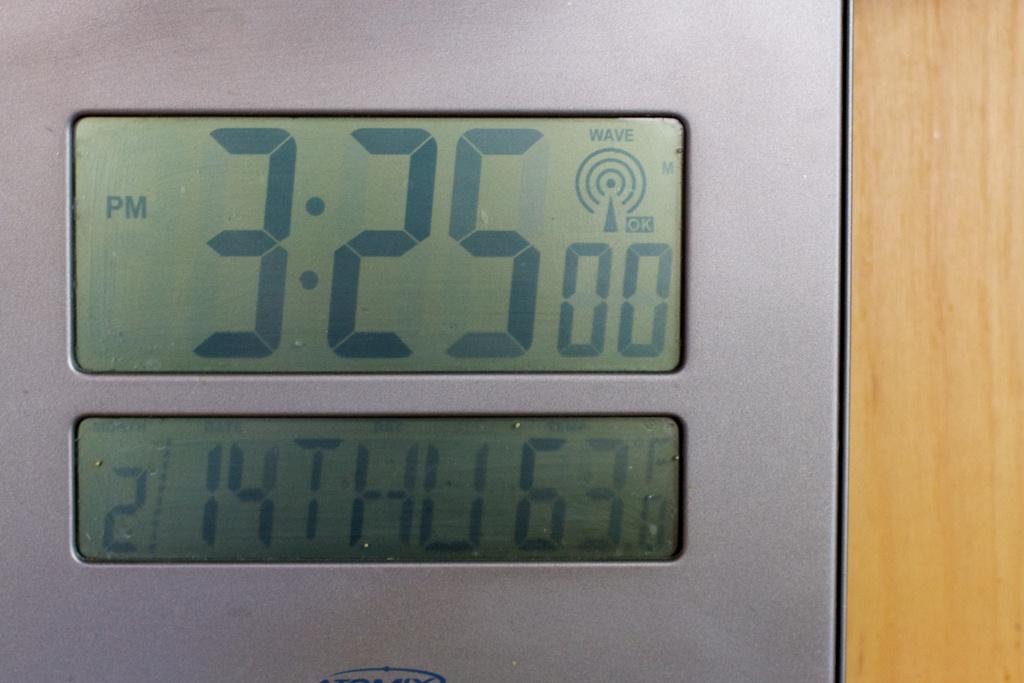What date is on the clock?
Give a very brief answer. 2/14. Is it am or pm right now?
Provide a succinct answer. Pm. 